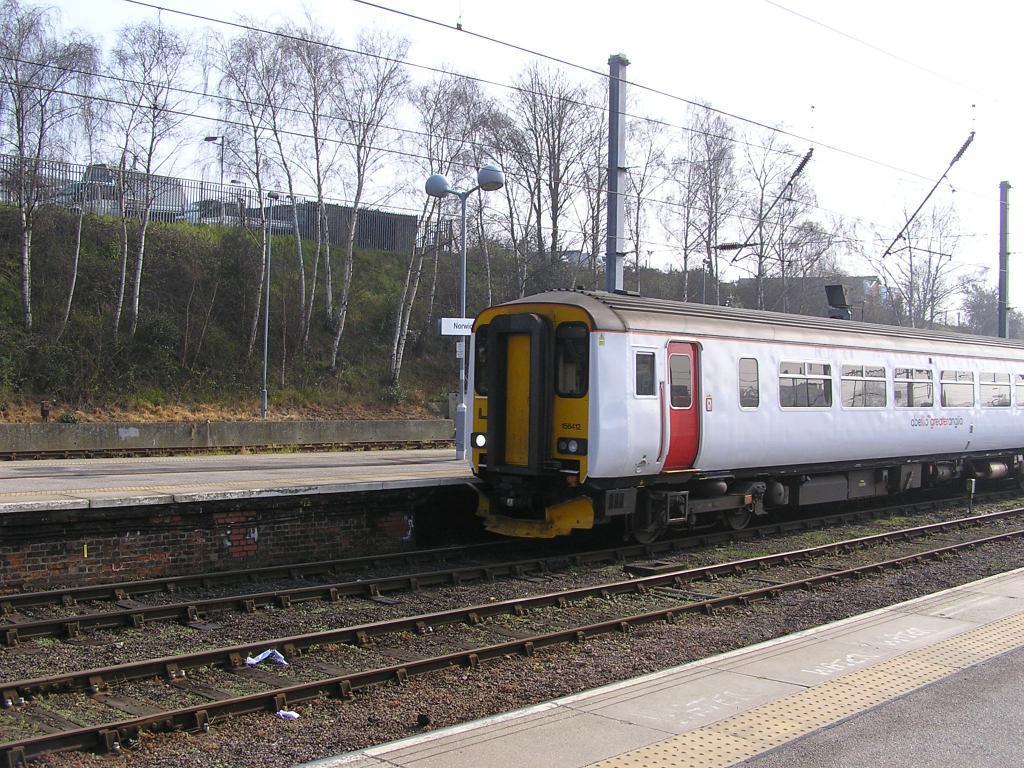Can you describe this image briefly? In the center of the image there is a train. There is a train track. In the background of the image there are trees. There are electric poles and wires. There is a fencing. 